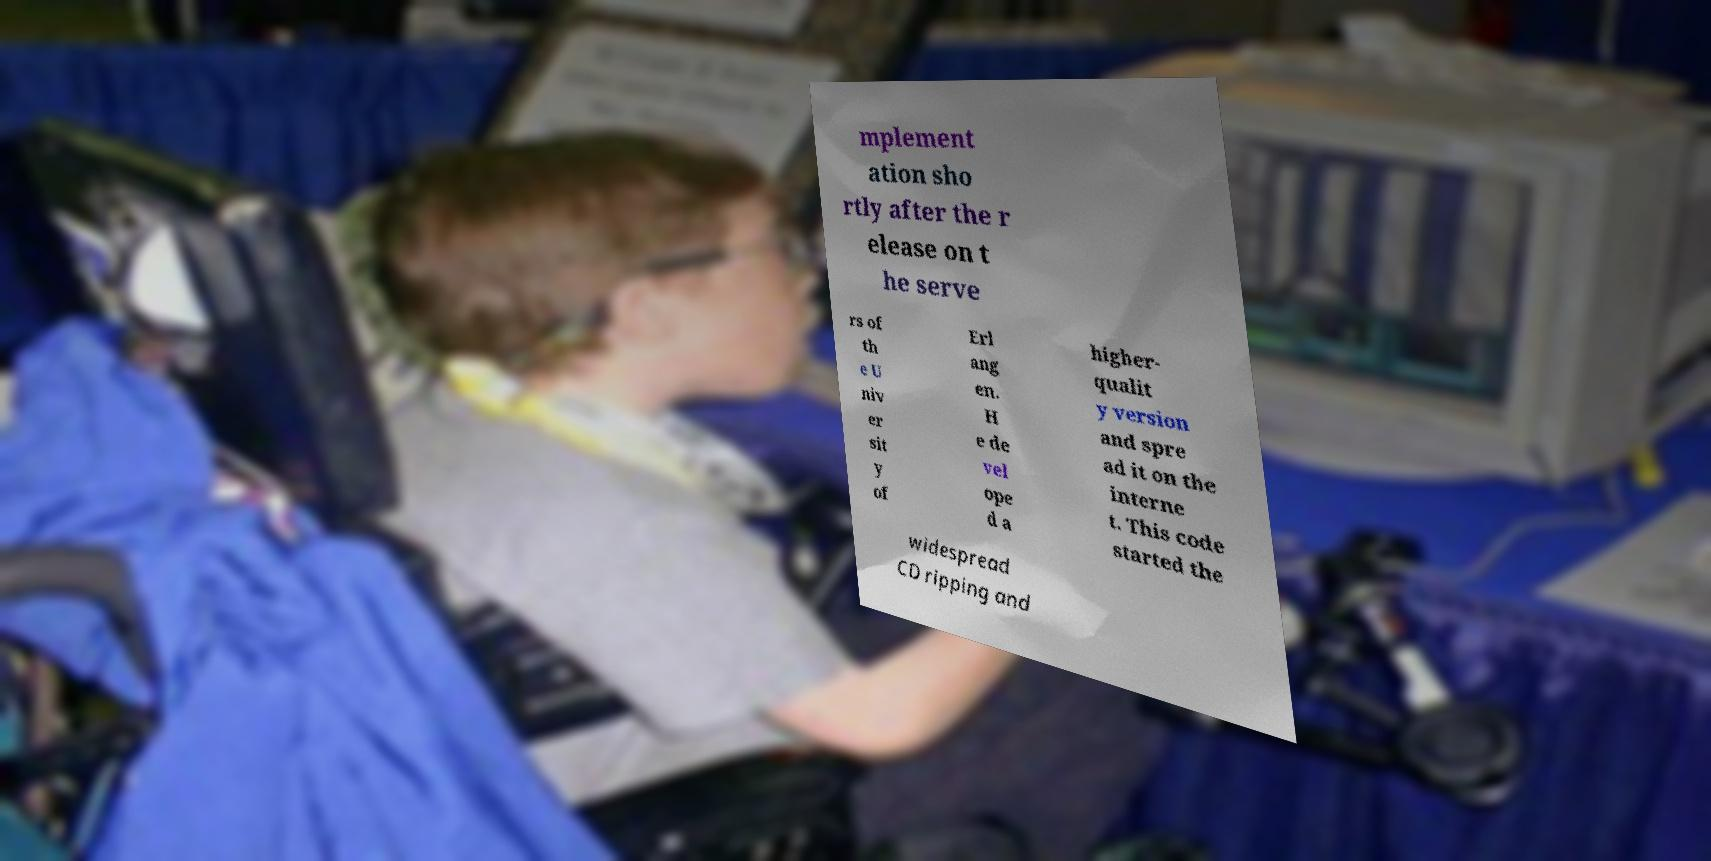I need the written content from this picture converted into text. Can you do that? mplement ation sho rtly after the r elease on t he serve rs of th e U niv er sit y of Erl ang en. H e de vel ope d a higher- qualit y version and spre ad it on the interne t. This code started the widespread CD ripping and 